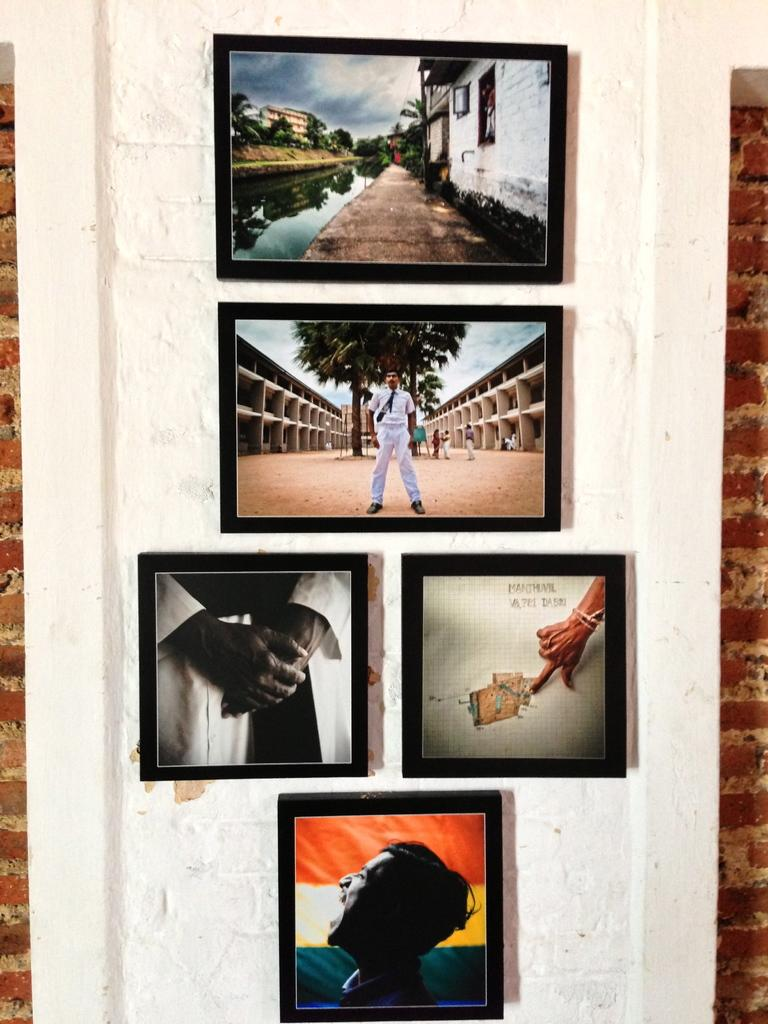What type of wall has frames attached to it in the image? There are frames attached to both a white wall and a brick wall in the image. What can be seen in the background of the image? Buildings, trees, and water are visible in the image. What architectural features are present in the image? Windows are present in the image. Are there any living beings visible in the image? Yes, there are people visible in the image. What type of magic is being performed by the horse in the image? There is no horse present in the image, and therefore no magic being performed. What time is displayed on the clock in the image? There is no clock present in the image. 